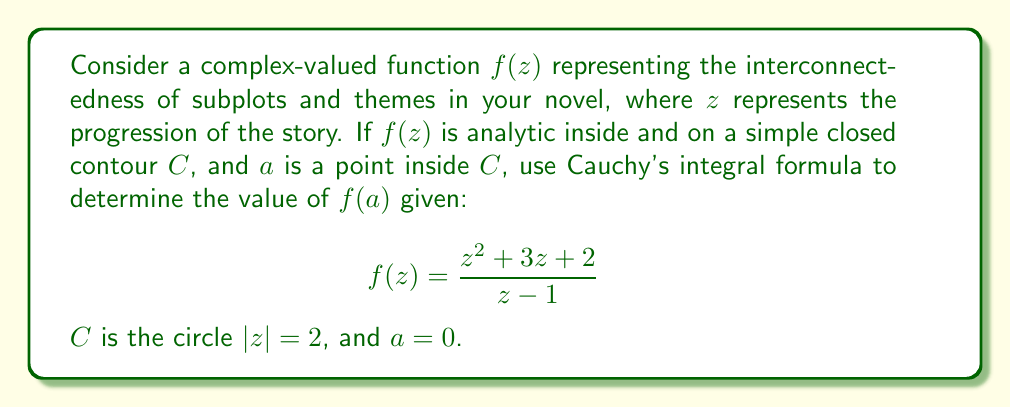Could you help me with this problem? To solve this problem using Cauchy's integral formula, we'll follow these steps:

1) Cauchy's integral formula states that for an analytic function $f(z)$ inside and on a simple closed contour $C$, and for any point $a$ inside $C$:

   $$f(a) = \frac{1}{2\pi i} \oint_C \frac{f(z)}{z-a} dz$$

2) In our case, $a = 0$ and $f(z) = \frac{z^2 + 3z + 2}{z - 1}$

3) Substituting these into Cauchy's formula:

   $$f(0) = \frac{1}{2\pi i} \oint_{|z|=2} \frac{\frac{z^2 + 3z + 2}{z - 1}}{z-0} dz$$

4) Simplify:

   $$f(0) = \frac{1}{2\pi i} \oint_{|z|=2} \frac{z^2 + 3z + 2}{z(z - 1)} dz$$

5) The function inside the integral has two singularities: at $z = 0$ and $z = 1$. However, only $z = 0$ is inside our contour $|z| = 2$.

6) We can simplify our function by partial fraction decomposition:

   $$\frac{z^2 + 3z + 2}{z(z - 1)} = \frac{A}{z} + \frac{B}{z-1}$$

   where $A$ and $B$ are constants we need to determine.

7) Multiplying both sides by $z(z-1)$:

   $$z^2 + 3z + 2 = A(z-1) + Bz$$

8) Comparing coefficients:
   $z^2: A + B = 1$
   $z^1: -A + B = 3$
   $z^0: -A = 2$

   Solving this system, we get $A = -2$ and $B = 3$

9) So our function becomes:

   $$\frac{z^2 + 3z + 2}{z(z - 1)} = -\frac{2}{z} + \frac{3}{z-1}$$

10) By Cauchy's integral formula, the value of $f(0)$ is $2\pi i$ times the residue at $z = 0$, which is the coefficient of $\frac{1}{z}$ in our decomposed function.

11) Therefore, $f(0) = 2\pi i \cdot (-2) = -4\pi i$
Answer: $f(0) = -4\pi i$ 